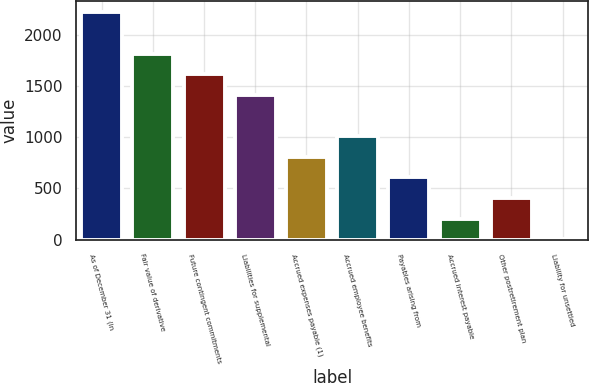<chart> <loc_0><loc_0><loc_500><loc_500><bar_chart><fcel>As of December 31 (in<fcel>Fair value of derivative<fcel>Future contingent commitments<fcel>Liabilities for supplemental<fcel>Accrued expenses payable (1)<fcel>Accrued employee benefits<fcel>Payables arising from<fcel>Accrued interest payable<fcel>Other postretirement plan<fcel>Liability for unsettled<nl><fcel>2216<fcel>1814<fcel>1613<fcel>1412<fcel>809<fcel>1010<fcel>608<fcel>206<fcel>407<fcel>5<nl></chart> 